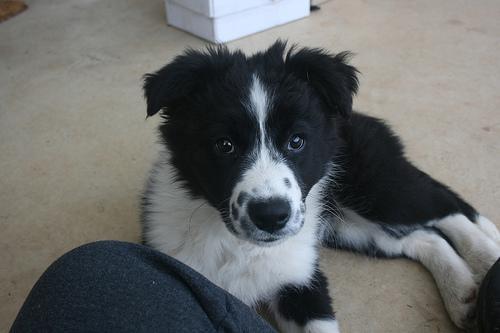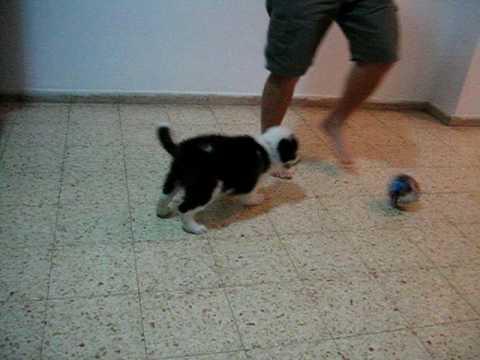The first image is the image on the left, the second image is the image on the right. Analyze the images presented: Is the assertion "In one of the images there is a black and white dog lying on the floor." valid? Answer yes or no. Yes. The first image is the image on the left, the second image is the image on the right. Assess this claim about the two images: "At least one image includes a person in jeans next to a dog, and each image includes a dog that is sitting.". Correct or not? Answer yes or no. No. 